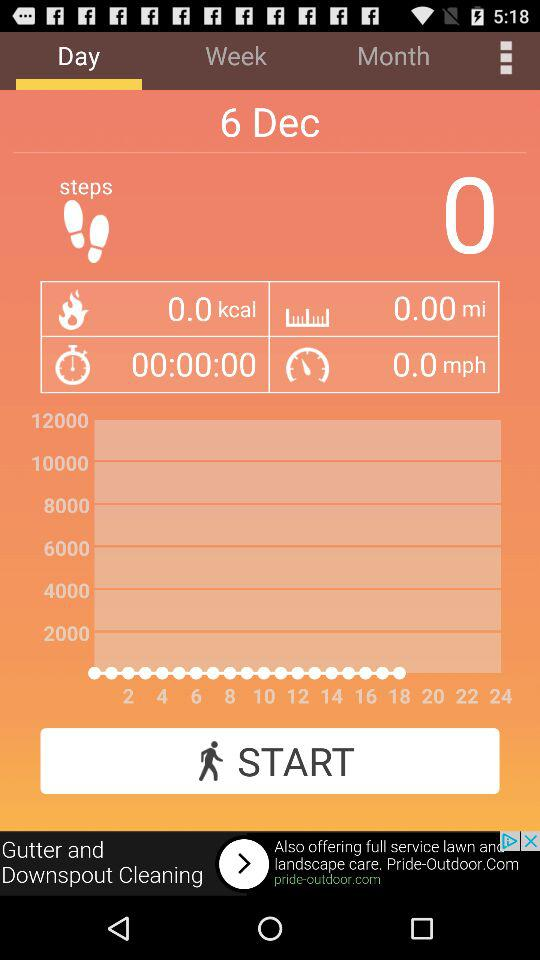How far has it travelled? It has travelled 0 miles. 